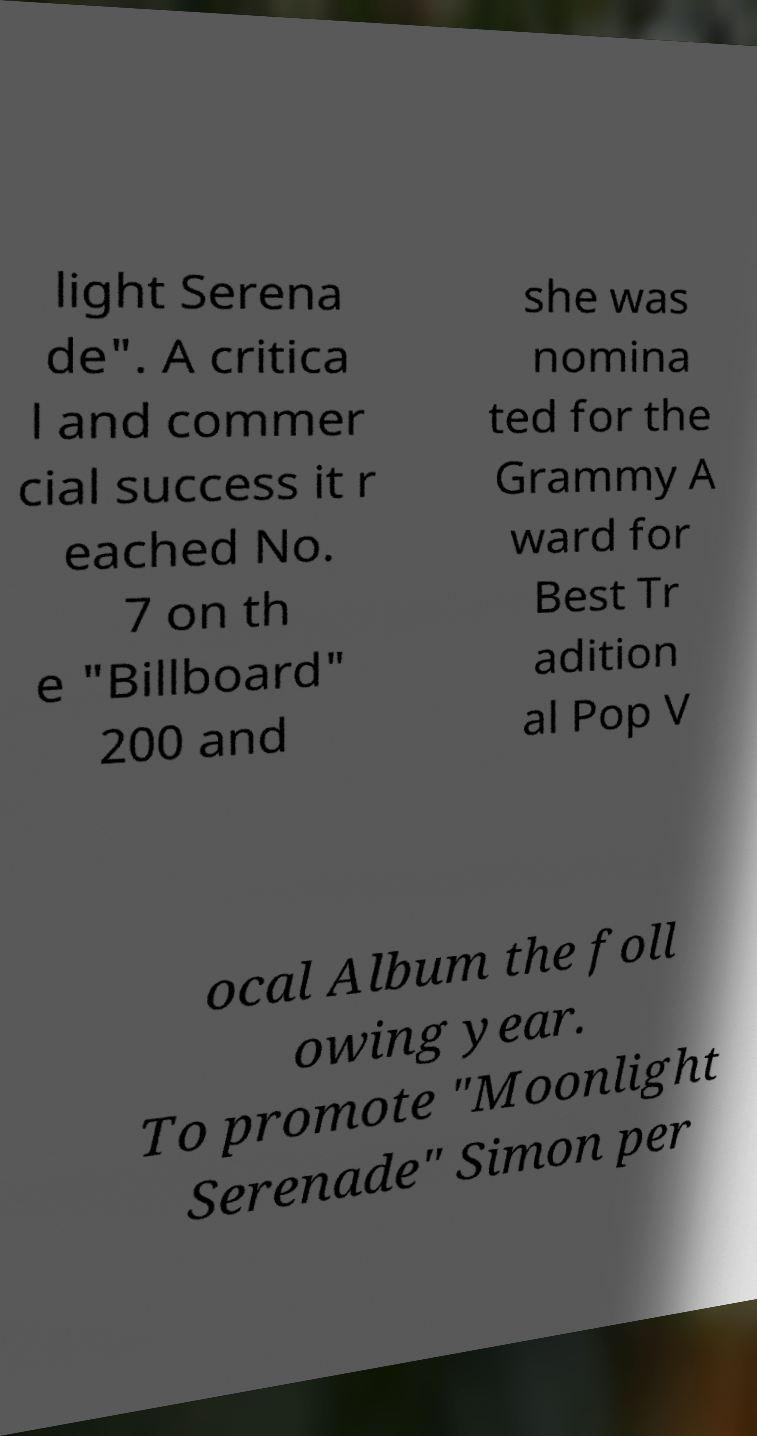What messages or text are displayed in this image? I need them in a readable, typed format. light Serena de". A critica l and commer cial success it r eached No. 7 on th e "Billboard" 200 and she was nomina ted for the Grammy A ward for Best Tr adition al Pop V ocal Album the foll owing year. To promote "Moonlight Serenade" Simon per 